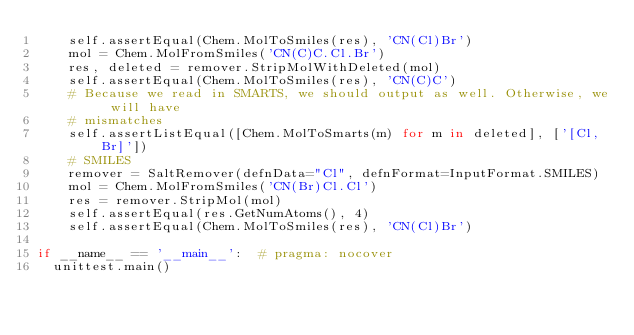<code> <loc_0><loc_0><loc_500><loc_500><_Python_>    self.assertEqual(Chem.MolToSmiles(res), 'CN(Cl)Br')
    mol = Chem.MolFromSmiles('CN(C)C.Cl.Br')
    res, deleted = remover.StripMolWithDeleted(mol)
    self.assertEqual(Chem.MolToSmiles(res), 'CN(C)C')
    # Because we read in SMARTS, we should output as well. Otherwise, we will have
    # mismatches
    self.assertListEqual([Chem.MolToSmarts(m) for m in deleted], ['[Cl,Br]'])
    # SMILES
    remover = SaltRemover(defnData="Cl", defnFormat=InputFormat.SMILES)
    mol = Chem.MolFromSmiles('CN(Br)Cl.Cl')
    res = remover.StripMol(mol)
    self.assertEqual(res.GetNumAtoms(), 4)
    self.assertEqual(Chem.MolToSmiles(res), 'CN(Cl)Br')

if __name__ == '__main__':  # pragma: nocover
  unittest.main()
</code> 